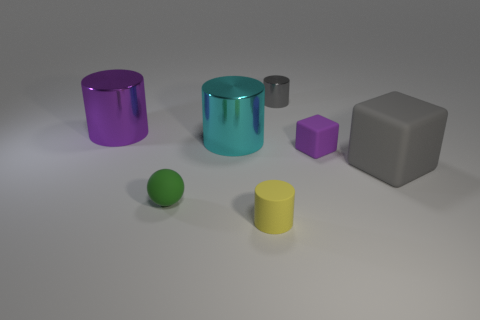Subtract all brown cylinders. Subtract all green cubes. How many cylinders are left? 4 Add 2 large brown cylinders. How many objects exist? 9 Subtract all balls. How many objects are left? 6 Add 6 small gray shiny cylinders. How many small gray shiny cylinders exist? 7 Subtract 0 red balls. How many objects are left? 7 Subtract all tiny purple matte things. Subtract all small yellow cylinders. How many objects are left? 5 Add 7 rubber balls. How many rubber balls are left? 8 